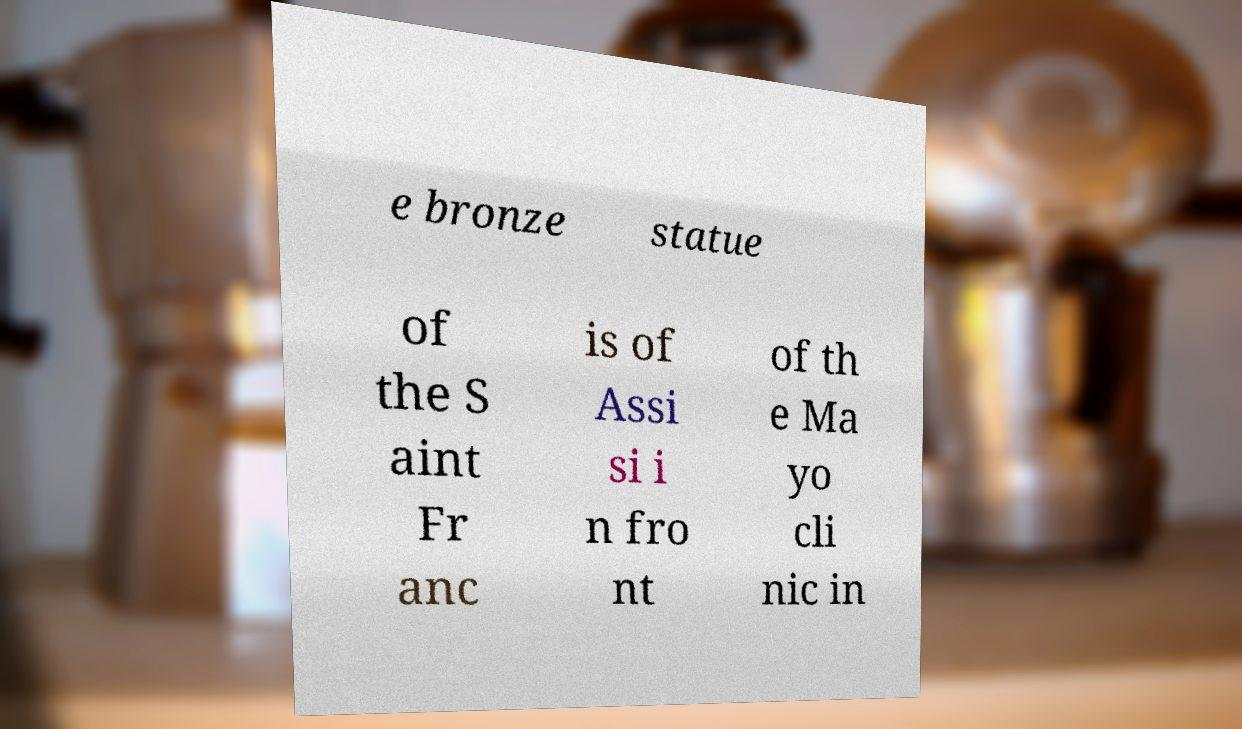What messages or text are displayed in this image? I need them in a readable, typed format. e bronze statue of the S aint Fr anc is of Assi si i n fro nt of th e Ma yo cli nic in 